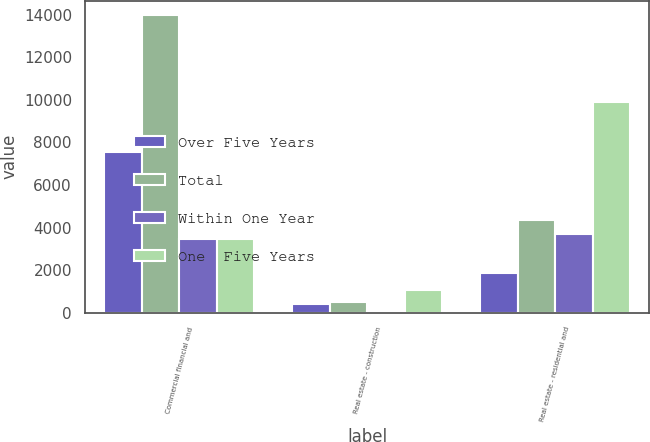<chart> <loc_0><loc_0><loc_500><loc_500><stacked_bar_chart><ecel><fcel>Commercial financial and<fcel>Real estate - construction<fcel>Real estate - residential and<nl><fcel>Over Five Years<fcel>7551<fcel>444<fcel>1858<nl><fcel>Total<fcel>13957<fcel>534<fcel>4365<nl><fcel>Within One Year<fcel>3455<fcel>115<fcel>3684<nl><fcel>One  Five Years<fcel>3455<fcel>1093<fcel>9907<nl></chart> 